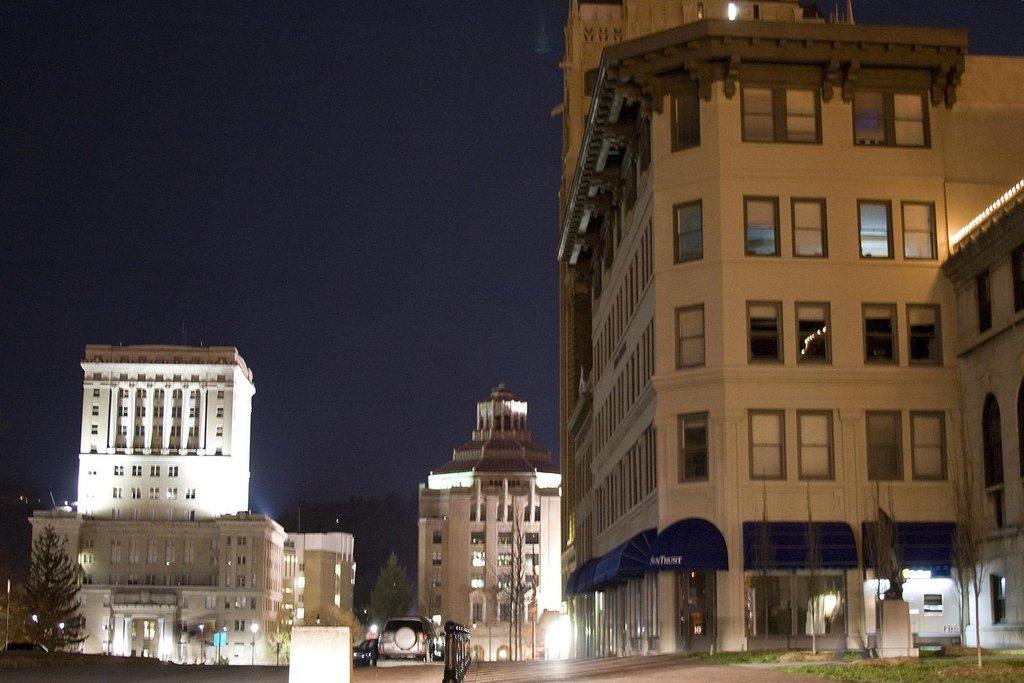What can be seen on the road in the image? There are vehicles on the road in the image. What type of natural elements are present in the image? There are trees in the image. What type of man-made structures are present in the image? There are buildings in the image. What type of illumination is present in the image? There are lights in the image. What can be seen in the background of the image? The sky is visible in the background of the image. Can you tell me how many bats are hanging from the trees in the image? There are no bats present in the image; it features vehicles on the road, trees, buildings, lights, and a visible sky. What type of rhythm can be heard coming from the buildings in the image? There is no indication of any sound or rhythm in the image, as it is a still photograph. 